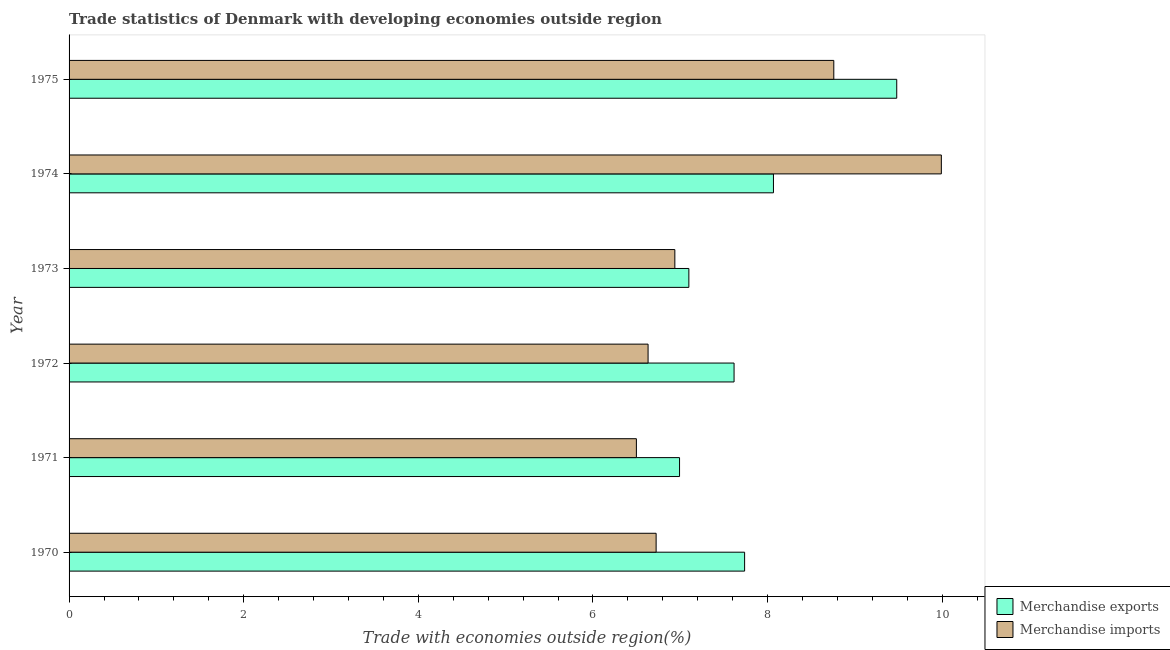How many different coloured bars are there?
Offer a terse response. 2. How many groups of bars are there?
Offer a very short reply. 6. Are the number of bars per tick equal to the number of legend labels?
Make the answer very short. Yes. How many bars are there on the 4th tick from the top?
Provide a succinct answer. 2. What is the label of the 2nd group of bars from the top?
Make the answer very short. 1974. In how many cases, is the number of bars for a given year not equal to the number of legend labels?
Ensure brevity in your answer.  0. What is the merchandise imports in 1975?
Offer a terse response. 8.76. Across all years, what is the maximum merchandise imports?
Provide a succinct answer. 9.99. Across all years, what is the minimum merchandise imports?
Keep it short and to the point. 6.5. In which year was the merchandise imports maximum?
Make the answer very short. 1974. What is the total merchandise exports in the graph?
Your answer should be compact. 46.99. What is the difference between the merchandise imports in 1974 and that in 1975?
Keep it short and to the point. 1.23. What is the difference between the merchandise imports in 1972 and the merchandise exports in 1970?
Give a very brief answer. -1.11. What is the average merchandise exports per year?
Keep it short and to the point. 7.83. In the year 1973, what is the difference between the merchandise imports and merchandise exports?
Make the answer very short. -0.16. In how many years, is the merchandise exports greater than 3.6 %?
Offer a terse response. 6. What is the ratio of the merchandise exports in 1971 to that in 1973?
Your answer should be compact. 0.98. Is the difference between the merchandise exports in 1974 and 1975 greater than the difference between the merchandise imports in 1974 and 1975?
Provide a short and direct response. No. What is the difference between the highest and the second highest merchandise exports?
Give a very brief answer. 1.41. What is the difference between the highest and the lowest merchandise imports?
Provide a short and direct response. 3.49. Is the sum of the merchandise exports in 1971 and 1974 greater than the maximum merchandise imports across all years?
Offer a very short reply. Yes. What does the 2nd bar from the top in 1971 represents?
Provide a succinct answer. Merchandise exports. What does the 1st bar from the bottom in 1975 represents?
Make the answer very short. Merchandise exports. Are all the bars in the graph horizontal?
Your response must be concise. Yes. What is the difference between two consecutive major ticks on the X-axis?
Your answer should be compact. 2. Are the values on the major ticks of X-axis written in scientific E-notation?
Provide a succinct answer. No. What is the title of the graph?
Make the answer very short. Trade statistics of Denmark with developing economies outside region. Does "Male labourers" appear as one of the legend labels in the graph?
Ensure brevity in your answer.  No. What is the label or title of the X-axis?
Give a very brief answer. Trade with economies outside region(%). What is the Trade with economies outside region(%) of Merchandise exports in 1970?
Ensure brevity in your answer.  7.74. What is the Trade with economies outside region(%) in Merchandise imports in 1970?
Your answer should be compact. 6.72. What is the Trade with economies outside region(%) of Merchandise exports in 1971?
Offer a very short reply. 6.99. What is the Trade with economies outside region(%) of Merchandise imports in 1971?
Provide a succinct answer. 6.5. What is the Trade with economies outside region(%) in Merchandise exports in 1972?
Offer a very short reply. 7.62. What is the Trade with economies outside region(%) of Merchandise imports in 1972?
Your answer should be compact. 6.63. What is the Trade with economies outside region(%) in Merchandise exports in 1973?
Offer a very short reply. 7.1. What is the Trade with economies outside region(%) in Merchandise imports in 1973?
Your answer should be compact. 6.94. What is the Trade with economies outside region(%) in Merchandise exports in 1974?
Give a very brief answer. 8.07. What is the Trade with economies outside region(%) of Merchandise imports in 1974?
Your answer should be compact. 9.99. What is the Trade with economies outside region(%) of Merchandise exports in 1975?
Your answer should be very brief. 9.48. What is the Trade with economies outside region(%) in Merchandise imports in 1975?
Your answer should be compact. 8.76. Across all years, what is the maximum Trade with economies outside region(%) of Merchandise exports?
Your answer should be compact. 9.48. Across all years, what is the maximum Trade with economies outside region(%) of Merchandise imports?
Give a very brief answer. 9.99. Across all years, what is the minimum Trade with economies outside region(%) in Merchandise exports?
Give a very brief answer. 6.99. Across all years, what is the minimum Trade with economies outside region(%) in Merchandise imports?
Your answer should be compact. 6.5. What is the total Trade with economies outside region(%) of Merchandise exports in the graph?
Ensure brevity in your answer.  46.99. What is the total Trade with economies outside region(%) in Merchandise imports in the graph?
Provide a succinct answer. 45.54. What is the difference between the Trade with economies outside region(%) in Merchandise exports in 1970 and that in 1971?
Keep it short and to the point. 0.75. What is the difference between the Trade with economies outside region(%) of Merchandise imports in 1970 and that in 1971?
Offer a very short reply. 0.23. What is the difference between the Trade with economies outside region(%) of Merchandise exports in 1970 and that in 1972?
Provide a succinct answer. 0.12. What is the difference between the Trade with economies outside region(%) of Merchandise imports in 1970 and that in 1972?
Provide a succinct answer. 0.09. What is the difference between the Trade with economies outside region(%) of Merchandise exports in 1970 and that in 1973?
Your response must be concise. 0.64. What is the difference between the Trade with economies outside region(%) of Merchandise imports in 1970 and that in 1973?
Keep it short and to the point. -0.21. What is the difference between the Trade with economies outside region(%) in Merchandise exports in 1970 and that in 1974?
Your response must be concise. -0.33. What is the difference between the Trade with economies outside region(%) of Merchandise imports in 1970 and that in 1974?
Give a very brief answer. -3.27. What is the difference between the Trade with economies outside region(%) in Merchandise exports in 1970 and that in 1975?
Offer a terse response. -1.74. What is the difference between the Trade with economies outside region(%) of Merchandise imports in 1970 and that in 1975?
Offer a very short reply. -2.04. What is the difference between the Trade with economies outside region(%) in Merchandise exports in 1971 and that in 1972?
Your answer should be compact. -0.62. What is the difference between the Trade with economies outside region(%) of Merchandise imports in 1971 and that in 1972?
Your answer should be compact. -0.13. What is the difference between the Trade with economies outside region(%) in Merchandise exports in 1971 and that in 1973?
Give a very brief answer. -0.11. What is the difference between the Trade with economies outside region(%) in Merchandise imports in 1971 and that in 1973?
Keep it short and to the point. -0.44. What is the difference between the Trade with economies outside region(%) of Merchandise exports in 1971 and that in 1974?
Your answer should be very brief. -1.08. What is the difference between the Trade with economies outside region(%) of Merchandise imports in 1971 and that in 1974?
Provide a short and direct response. -3.49. What is the difference between the Trade with economies outside region(%) in Merchandise exports in 1971 and that in 1975?
Your answer should be very brief. -2.49. What is the difference between the Trade with economies outside region(%) of Merchandise imports in 1971 and that in 1975?
Keep it short and to the point. -2.26. What is the difference between the Trade with economies outside region(%) in Merchandise exports in 1972 and that in 1973?
Give a very brief answer. 0.52. What is the difference between the Trade with economies outside region(%) of Merchandise imports in 1972 and that in 1973?
Keep it short and to the point. -0.31. What is the difference between the Trade with economies outside region(%) in Merchandise exports in 1972 and that in 1974?
Provide a short and direct response. -0.45. What is the difference between the Trade with economies outside region(%) in Merchandise imports in 1972 and that in 1974?
Give a very brief answer. -3.36. What is the difference between the Trade with economies outside region(%) in Merchandise exports in 1972 and that in 1975?
Your response must be concise. -1.86. What is the difference between the Trade with economies outside region(%) of Merchandise imports in 1972 and that in 1975?
Offer a terse response. -2.13. What is the difference between the Trade with economies outside region(%) in Merchandise exports in 1973 and that in 1974?
Your answer should be very brief. -0.97. What is the difference between the Trade with economies outside region(%) of Merchandise imports in 1973 and that in 1974?
Offer a very short reply. -3.05. What is the difference between the Trade with economies outside region(%) of Merchandise exports in 1973 and that in 1975?
Provide a short and direct response. -2.38. What is the difference between the Trade with economies outside region(%) of Merchandise imports in 1973 and that in 1975?
Give a very brief answer. -1.82. What is the difference between the Trade with economies outside region(%) of Merchandise exports in 1974 and that in 1975?
Your answer should be very brief. -1.41. What is the difference between the Trade with economies outside region(%) in Merchandise imports in 1974 and that in 1975?
Your answer should be compact. 1.23. What is the difference between the Trade with economies outside region(%) of Merchandise exports in 1970 and the Trade with economies outside region(%) of Merchandise imports in 1971?
Ensure brevity in your answer.  1.24. What is the difference between the Trade with economies outside region(%) of Merchandise exports in 1970 and the Trade with economies outside region(%) of Merchandise imports in 1972?
Offer a very short reply. 1.11. What is the difference between the Trade with economies outside region(%) in Merchandise exports in 1970 and the Trade with economies outside region(%) in Merchandise imports in 1973?
Your answer should be compact. 0.8. What is the difference between the Trade with economies outside region(%) in Merchandise exports in 1970 and the Trade with economies outside region(%) in Merchandise imports in 1974?
Your answer should be compact. -2.25. What is the difference between the Trade with economies outside region(%) in Merchandise exports in 1970 and the Trade with economies outside region(%) in Merchandise imports in 1975?
Make the answer very short. -1.02. What is the difference between the Trade with economies outside region(%) in Merchandise exports in 1971 and the Trade with economies outside region(%) in Merchandise imports in 1972?
Your answer should be very brief. 0.36. What is the difference between the Trade with economies outside region(%) in Merchandise exports in 1971 and the Trade with economies outside region(%) in Merchandise imports in 1973?
Keep it short and to the point. 0.05. What is the difference between the Trade with economies outside region(%) in Merchandise exports in 1971 and the Trade with economies outside region(%) in Merchandise imports in 1974?
Offer a very short reply. -3. What is the difference between the Trade with economies outside region(%) in Merchandise exports in 1971 and the Trade with economies outside region(%) in Merchandise imports in 1975?
Ensure brevity in your answer.  -1.77. What is the difference between the Trade with economies outside region(%) in Merchandise exports in 1972 and the Trade with economies outside region(%) in Merchandise imports in 1973?
Ensure brevity in your answer.  0.68. What is the difference between the Trade with economies outside region(%) of Merchandise exports in 1972 and the Trade with economies outside region(%) of Merchandise imports in 1974?
Your answer should be compact. -2.37. What is the difference between the Trade with economies outside region(%) of Merchandise exports in 1972 and the Trade with economies outside region(%) of Merchandise imports in 1975?
Make the answer very short. -1.14. What is the difference between the Trade with economies outside region(%) of Merchandise exports in 1973 and the Trade with economies outside region(%) of Merchandise imports in 1974?
Ensure brevity in your answer.  -2.89. What is the difference between the Trade with economies outside region(%) in Merchandise exports in 1973 and the Trade with economies outside region(%) in Merchandise imports in 1975?
Your answer should be very brief. -1.66. What is the difference between the Trade with economies outside region(%) in Merchandise exports in 1974 and the Trade with economies outside region(%) in Merchandise imports in 1975?
Your answer should be compact. -0.69. What is the average Trade with economies outside region(%) of Merchandise exports per year?
Give a very brief answer. 7.83. What is the average Trade with economies outside region(%) of Merchandise imports per year?
Ensure brevity in your answer.  7.59. In the year 1970, what is the difference between the Trade with economies outside region(%) in Merchandise exports and Trade with economies outside region(%) in Merchandise imports?
Make the answer very short. 1.01. In the year 1971, what is the difference between the Trade with economies outside region(%) of Merchandise exports and Trade with economies outside region(%) of Merchandise imports?
Offer a very short reply. 0.49. In the year 1972, what is the difference between the Trade with economies outside region(%) in Merchandise exports and Trade with economies outside region(%) in Merchandise imports?
Provide a short and direct response. 0.98. In the year 1973, what is the difference between the Trade with economies outside region(%) of Merchandise exports and Trade with economies outside region(%) of Merchandise imports?
Offer a terse response. 0.16. In the year 1974, what is the difference between the Trade with economies outside region(%) in Merchandise exports and Trade with economies outside region(%) in Merchandise imports?
Ensure brevity in your answer.  -1.92. In the year 1975, what is the difference between the Trade with economies outside region(%) of Merchandise exports and Trade with economies outside region(%) of Merchandise imports?
Your response must be concise. 0.72. What is the ratio of the Trade with economies outside region(%) of Merchandise exports in 1970 to that in 1971?
Your answer should be very brief. 1.11. What is the ratio of the Trade with economies outside region(%) in Merchandise imports in 1970 to that in 1971?
Offer a terse response. 1.03. What is the ratio of the Trade with economies outside region(%) in Merchandise exports in 1970 to that in 1972?
Keep it short and to the point. 1.02. What is the ratio of the Trade with economies outside region(%) of Merchandise imports in 1970 to that in 1972?
Your answer should be very brief. 1.01. What is the ratio of the Trade with economies outside region(%) of Merchandise exports in 1970 to that in 1973?
Your answer should be compact. 1.09. What is the ratio of the Trade with economies outside region(%) of Merchandise imports in 1970 to that in 1973?
Offer a terse response. 0.97. What is the ratio of the Trade with economies outside region(%) of Merchandise imports in 1970 to that in 1974?
Provide a succinct answer. 0.67. What is the ratio of the Trade with economies outside region(%) in Merchandise exports in 1970 to that in 1975?
Your answer should be compact. 0.82. What is the ratio of the Trade with economies outside region(%) of Merchandise imports in 1970 to that in 1975?
Your answer should be very brief. 0.77. What is the ratio of the Trade with economies outside region(%) of Merchandise exports in 1971 to that in 1972?
Your answer should be compact. 0.92. What is the ratio of the Trade with economies outside region(%) in Merchandise imports in 1971 to that in 1972?
Keep it short and to the point. 0.98. What is the ratio of the Trade with economies outside region(%) in Merchandise exports in 1971 to that in 1973?
Provide a succinct answer. 0.98. What is the ratio of the Trade with economies outside region(%) in Merchandise imports in 1971 to that in 1973?
Your answer should be compact. 0.94. What is the ratio of the Trade with economies outside region(%) of Merchandise exports in 1971 to that in 1974?
Give a very brief answer. 0.87. What is the ratio of the Trade with economies outside region(%) in Merchandise imports in 1971 to that in 1974?
Your response must be concise. 0.65. What is the ratio of the Trade with economies outside region(%) in Merchandise exports in 1971 to that in 1975?
Keep it short and to the point. 0.74. What is the ratio of the Trade with economies outside region(%) in Merchandise imports in 1971 to that in 1975?
Ensure brevity in your answer.  0.74. What is the ratio of the Trade with economies outside region(%) of Merchandise exports in 1972 to that in 1973?
Offer a very short reply. 1.07. What is the ratio of the Trade with economies outside region(%) of Merchandise imports in 1972 to that in 1973?
Your answer should be very brief. 0.96. What is the ratio of the Trade with economies outside region(%) of Merchandise exports in 1972 to that in 1974?
Your answer should be compact. 0.94. What is the ratio of the Trade with economies outside region(%) of Merchandise imports in 1972 to that in 1974?
Provide a short and direct response. 0.66. What is the ratio of the Trade with economies outside region(%) in Merchandise exports in 1972 to that in 1975?
Provide a succinct answer. 0.8. What is the ratio of the Trade with economies outside region(%) in Merchandise imports in 1972 to that in 1975?
Keep it short and to the point. 0.76. What is the ratio of the Trade with economies outside region(%) in Merchandise exports in 1973 to that in 1974?
Keep it short and to the point. 0.88. What is the ratio of the Trade with economies outside region(%) in Merchandise imports in 1973 to that in 1974?
Provide a short and direct response. 0.69. What is the ratio of the Trade with economies outside region(%) of Merchandise exports in 1973 to that in 1975?
Keep it short and to the point. 0.75. What is the ratio of the Trade with economies outside region(%) in Merchandise imports in 1973 to that in 1975?
Your answer should be compact. 0.79. What is the ratio of the Trade with economies outside region(%) in Merchandise exports in 1974 to that in 1975?
Your response must be concise. 0.85. What is the ratio of the Trade with economies outside region(%) in Merchandise imports in 1974 to that in 1975?
Offer a very short reply. 1.14. What is the difference between the highest and the second highest Trade with economies outside region(%) in Merchandise exports?
Give a very brief answer. 1.41. What is the difference between the highest and the second highest Trade with economies outside region(%) in Merchandise imports?
Offer a very short reply. 1.23. What is the difference between the highest and the lowest Trade with economies outside region(%) in Merchandise exports?
Ensure brevity in your answer.  2.49. What is the difference between the highest and the lowest Trade with economies outside region(%) of Merchandise imports?
Provide a short and direct response. 3.49. 